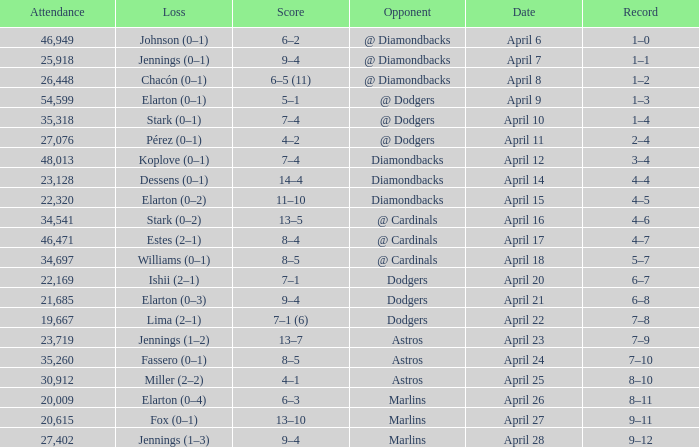Name the score when the opponent was the dodgers on april 21 9–4. 